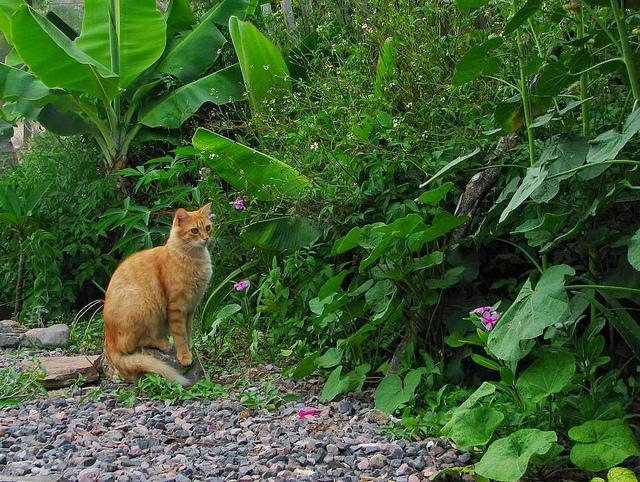Is this in a zoo?
Write a very short answer. No. Are there trees in this photo?
Answer briefly. No. Is this a house cat?
Be succinct. Yes. What color is the animal?
Concise answer only. Orange. What color are the little flowers?
Quick response, please. Purple. Is this a concrete surface?
Answer briefly. No. What animal is in the picture?
Quick response, please. Cat. 